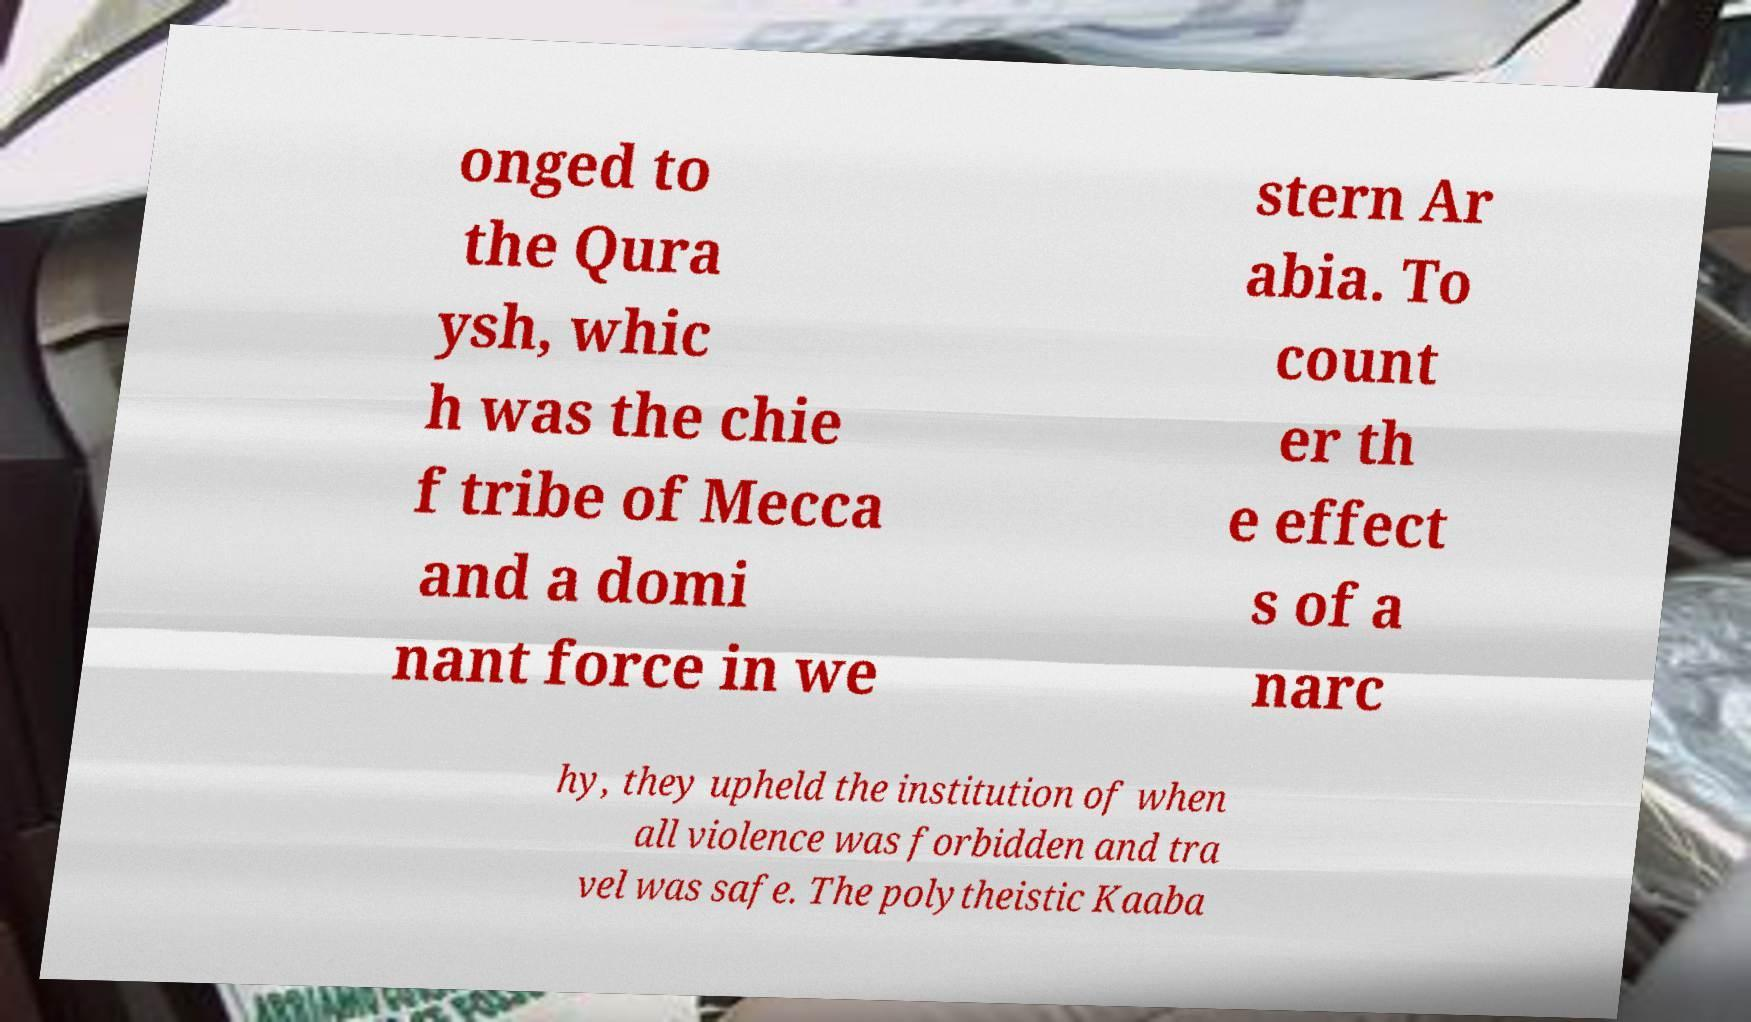For documentation purposes, I need the text within this image transcribed. Could you provide that? onged to the Qura ysh, whic h was the chie f tribe of Mecca and a domi nant force in we stern Ar abia. To count er th e effect s of a narc hy, they upheld the institution of when all violence was forbidden and tra vel was safe. The polytheistic Kaaba 